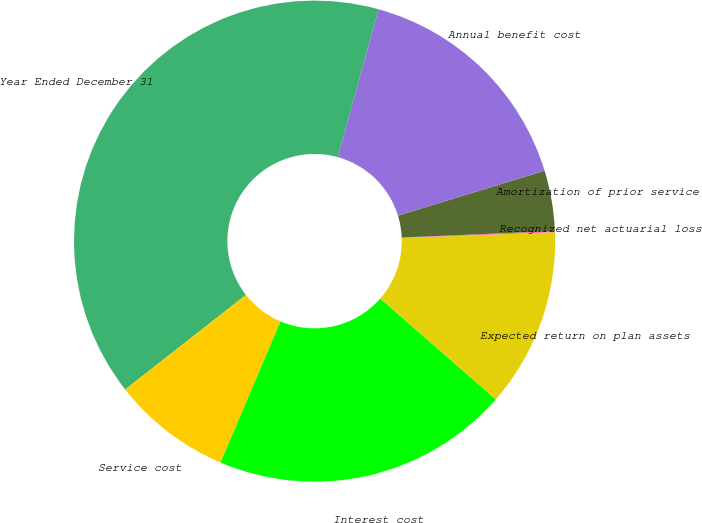<chart> <loc_0><loc_0><loc_500><loc_500><pie_chart><fcel>Year Ended December 31<fcel>Service cost<fcel>Interest cost<fcel>Expected return on plan assets<fcel>Recognized net actuarial loss<fcel>Amortization of prior service<fcel>Annual benefit cost<nl><fcel>39.86%<fcel>8.03%<fcel>19.97%<fcel>12.01%<fcel>0.08%<fcel>4.06%<fcel>15.99%<nl></chart> 